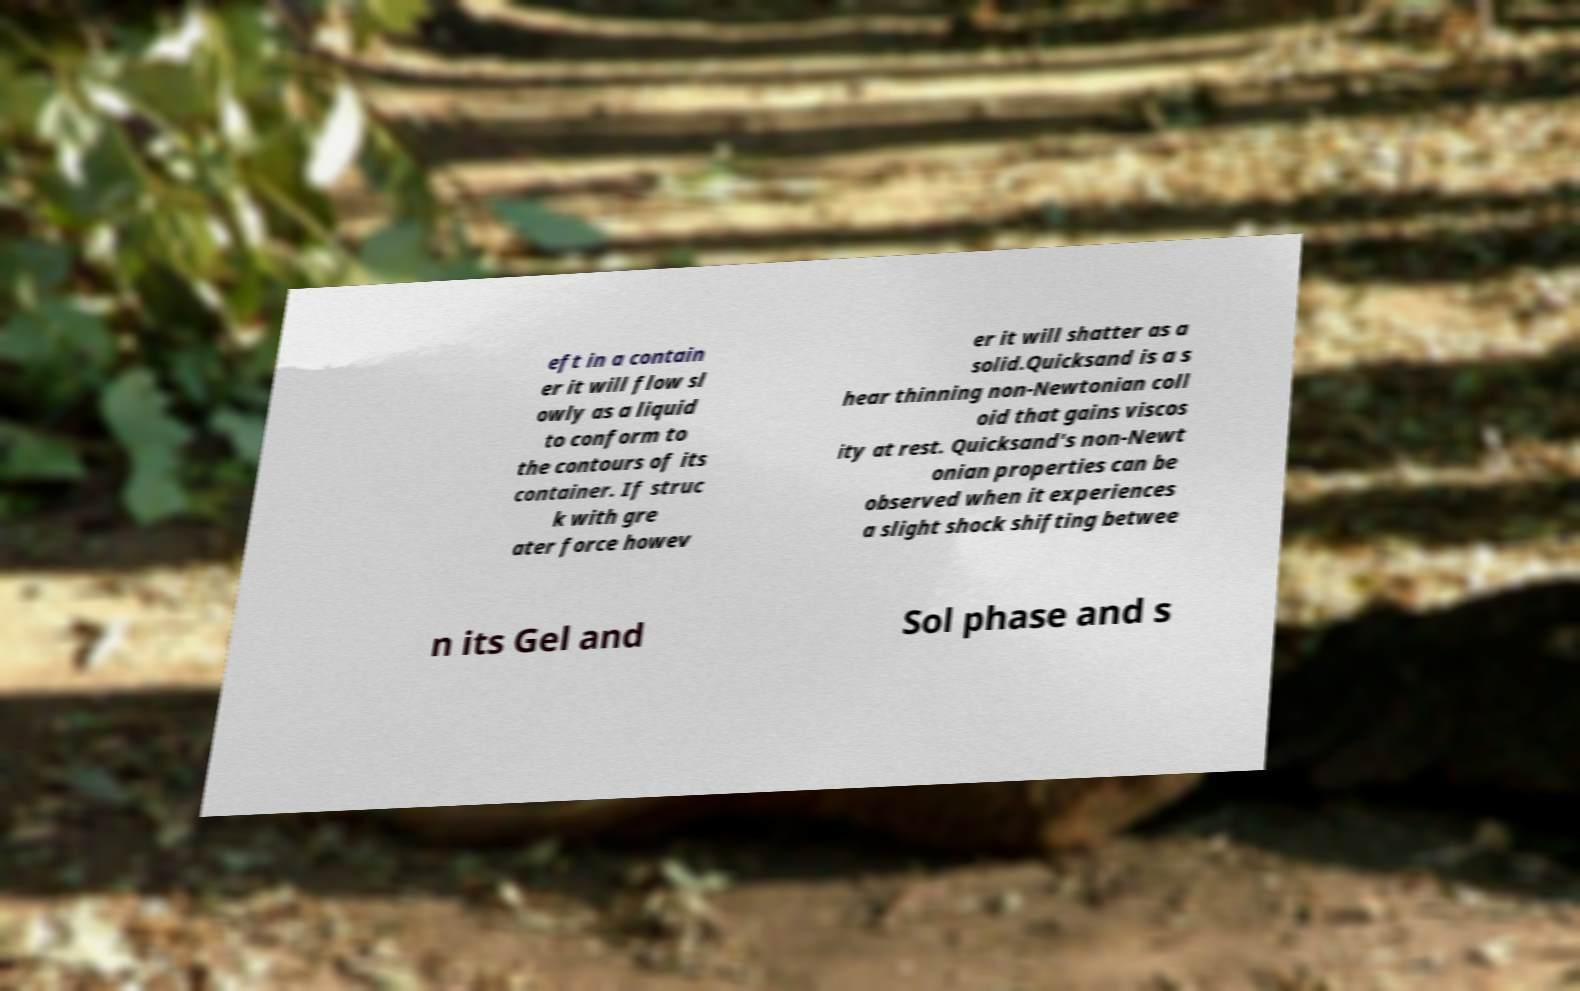Could you extract and type out the text from this image? eft in a contain er it will flow sl owly as a liquid to conform to the contours of its container. If struc k with gre ater force howev er it will shatter as a solid.Quicksand is a s hear thinning non-Newtonian coll oid that gains viscos ity at rest. Quicksand's non-Newt onian properties can be observed when it experiences a slight shock shifting betwee n its Gel and Sol phase and s 